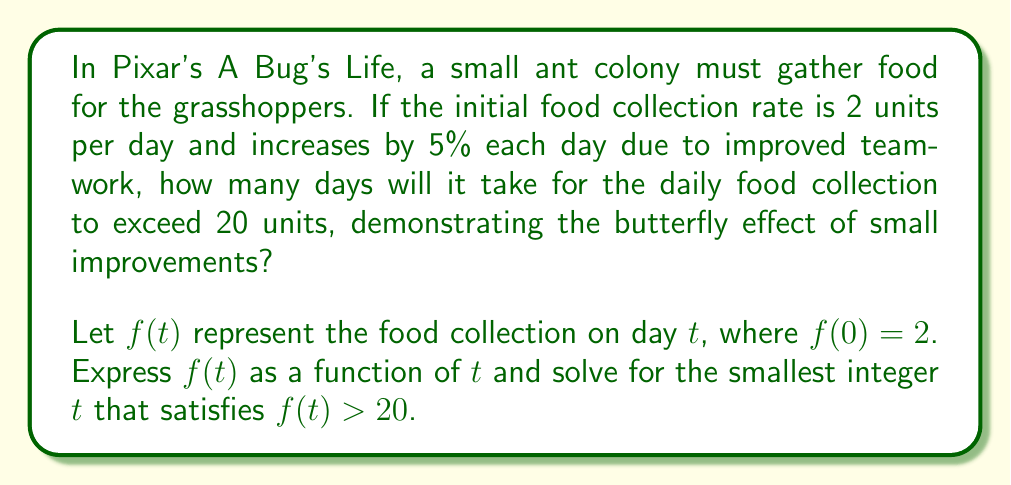Show me your answer to this math problem. Let's approach this step-by-step:

1) The food collection increases by 5% each day. This means we multiply the previous day's collection by 1.05 each day.

2) We can express this as a geometric sequence:
   $f(t) = 2 \cdot (1.05)^t$

3) We need to find the smallest integer $t$ for which $f(t) > 20$:
   $2 \cdot (1.05)^t > 20$

4) Dividing both sides by 2:
   $(1.05)^t > 10$

5) Taking the natural logarithm of both sides:
   $t \cdot \ln(1.05) > \ln(10)$

6) Solving for $t$:
   $t > \frac{\ln(10)}{\ln(1.05)} \approx 47.7344$

7) Since we need the smallest integer $t$, we round up to the next whole number.

8) To verify:
   $f(47) = 2 \cdot (1.05)^{47} \approx 19.8395$
   $f(48) = 2 \cdot (1.05)^{48} \approx 20.8315$

This demonstrates the butterfly effect, where small daily improvements lead to significant changes over time, much like how small actions in the ant colony lead to big changes in the movie.
Answer: 48 days 